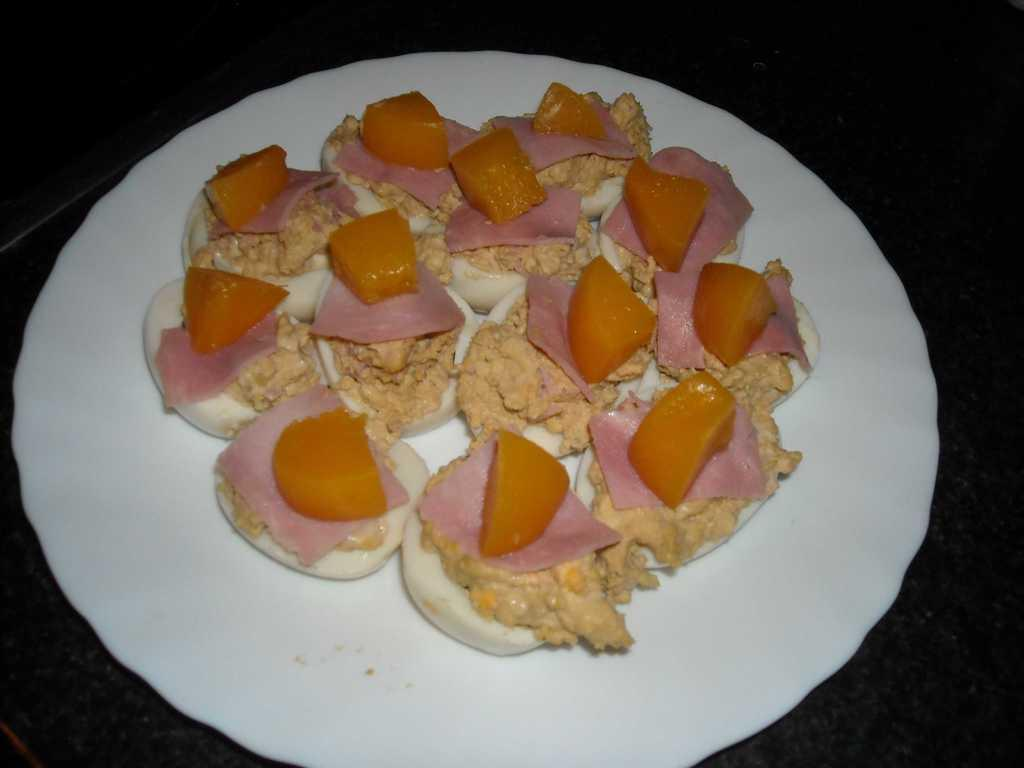What is present on the plate in the image? There is food on the plate in the image. What can be seen in the background of the image? The background of the image is black. What type of needle is being used to sew in the image? There is no needle or sewing activity present in the image. 